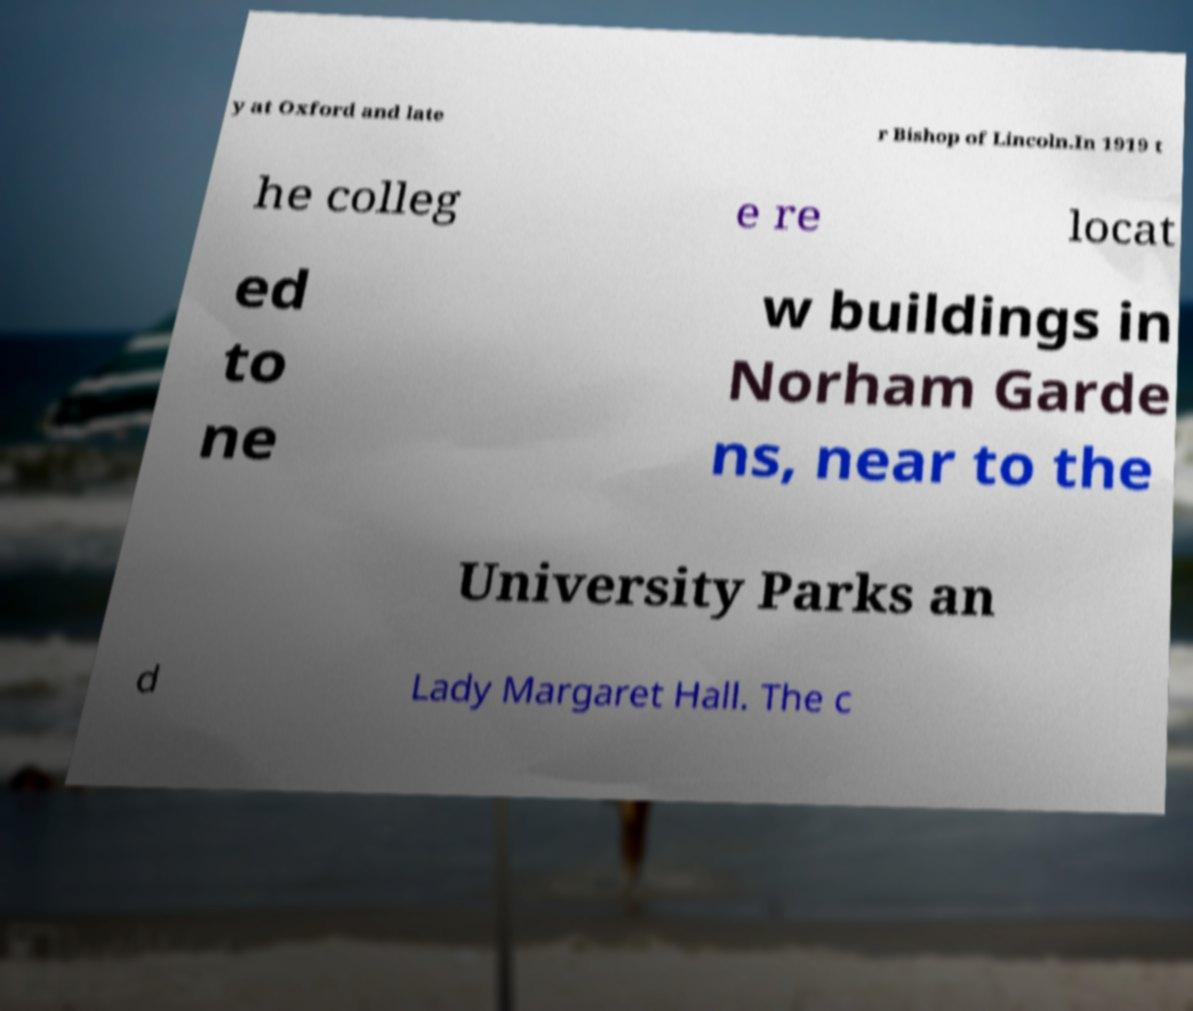There's text embedded in this image that I need extracted. Can you transcribe it verbatim? y at Oxford and late r Bishop of Lincoln.In 1919 t he colleg e re locat ed to ne w buildings in Norham Garde ns, near to the University Parks an d Lady Margaret Hall. The c 